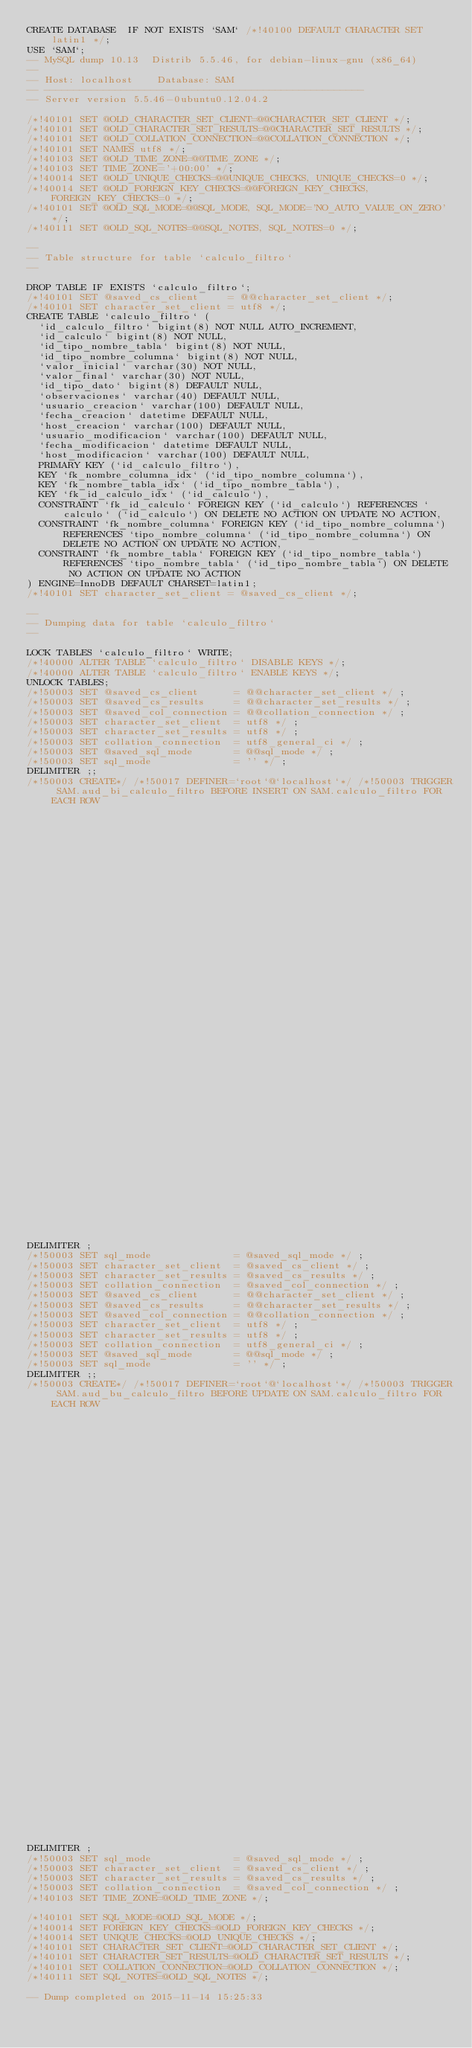<code> <loc_0><loc_0><loc_500><loc_500><_SQL_>CREATE DATABASE  IF NOT EXISTS `SAM` /*!40100 DEFAULT CHARACTER SET latin1 */;
USE `SAM`;
-- MySQL dump 10.13  Distrib 5.5.46, for debian-linux-gnu (x86_64)
--
-- Host: localhost    Database: SAM
-- ------------------------------------------------------
-- Server version	5.5.46-0ubuntu0.12.04.2

/*!40101 SET @OLD_CHARACTER_SET_CLIENT=@@CHARACTER_SET_CLIENT */;
/*!40101 SET @OLD_CHARACTER_SET_RESULTS=@@CHARACTER_SET_RESULTS */;
/*!40101 SET @OLD_COLLATION_CONNECTION=@@COLLATION_CONNECTION */;
/*!40101 SET NAMES utf8 */;
/*!40103 SET @OLD_TIME_ZONE=@@TIME_ZONE */;
/*!40103 SET TIME_ZONE='+00:00' */;
/*!40014 SET @OLD_UNIQUE_CHECKS=@@UNIQUE_CHECKS, UNIQUE_CHECKS=0 */;
/*!40014 SET @OLD_FOREIGN_KEY_CHECKS=@@FOREIGN_KEY_CHECKS, FOREIGN_KEY_CHECKS=0 */;
/*!40101 SET @OLD_SQL_MODE=@@SQL_MODE, SQL_MODE='NO_AUTO_VALUE_ON_ZERO' */;
/*!40111 SET @OLD_SQL_NOTES=@@SQL_NOTES, SQL_NOTES=0 */;

--
-- Table structure for table `calculo_filtro`
--

DROP TABLE IF EXISTS `calculo_filtro`;
/*!40101 SET @saved_cs_client     = @@character_set_client */;
/*!40101 SET character_set_client = utf8 */;
CREATE TABLE `calculo_filtro` (
  `id_calculo_filtro` bigint(8) NOT NULL AUTO_INCREMENT,
  `id_calculo` bigint(8) NOT NULL,
  `id_tipo_nombre_tabla` bigint(8) NOT NULL,
  `id_tipo_nombre_columna` bigint(8) NOT NULL,
  `valor_inicial` varchar(30) NOT NULL,
  `valor_final` varchar(30) NOT NULL,
  `id_tipo_dato` bigint(8) DEFAULT NULL,
  `observaciones` varchar(40) DEFAULT NULL,
  `usuario_creacion` varchar(100) DEFAULT NULL,
  `fecha_creacion` datetime DEFAULT NULL,
  `host_creacion` varchar(100) DEFAULT NULL,
  `usuario_modificacion` varchar(100) DEFAULT NULL,
  `fecha_modificacion` datetime DEFAULT NULL,
  `host_modificacion` varchar(100) DEFAULT NULL,
  PRIMARY KEY (`id_calculo_filtro`),
  KEY `fk_nombre_columna_idx` (`id_tipo_nombre_columna`),
  KEY `fk_nombre_tabla_idx` (`id_tipo_nombre_tabla`),
  KEY `fk_id_calculo_idx` (`id_calculo`),
  CONSTRAINT `fk_id_calculo` FOREIGN KEY (`id_calculo`) REFERENCES `calculo` (`id_calculo`) ON DELETE NO ACTION ON UPDATE NO ACTION,
  CONSTRAINT `fk_nombre_columna` FOREIGN KEY (`id_tipo_nombre_columna`) REFERENCES `tipo_nombre_columna` (`id_tipo_nombre_columna`) ON DELETE NO ACTION ON UPDATE NO ACTION,
  CONSTRAINT `fk_nombre_tabla` FOREIGN KEY (`id_tipo_nombre_tabla`) REFERENCES `tipo_nombre_tabla` (`id_tipo_nombre_tabla`) ON DELETE NO ACTION ON UPDATE NO ACTION
) ENGINE=InnoDB DEFAULT CHARSET=latin1;
/*!40101 SET character_set_client = @saved_cs_client */;

--
-- Dumping data for table `calculo_filtro`
--

LOCK TABLES `calculo_filtro` WRITE;
/*!40000 ALTER TABLE `calculo_filtro` DISABLE KEYS */;
/*!40000 ALTER TABLE `calculo_filtro` ENABLE KEYS */;
UNLOCK TABLES;
/*!50003 SET @saved_cs_client      = @@character_set_client */ ;
/*!50003 SET @saved_cs_results     = @@character_set_results */ ;
/*!50003 SET @saved_col_connection = @@collation_connection */ ;
/*!50003 SET character_set_client  = utf8 */ ;
/*!50003 SET character_set_results = utf8 */ ;
/*!50003 SET collation_connection  = utf8_general_ci */ ;
/*!50003 SET @saved_sql_mode       = @@sql_mode */ ;
/*!50003 SET sql_mode              = '' */ ;
DELIMITER ;;
/*!50003 CREATE*/ /*!50017 DEFINER=`root`@`localhost`*/ /*!50003 TRIGGER SAM.aud_bi_calculo_filtro BEFORE INSERT ON SAM.calculo_filtro FOR EACH ROW 
                                                                                BEGIN 
                                                                                	set new.fecha_creacion := NOW(); 
                                                                                	set new.usuario_creacion :=  user(); 
                                                                                	set new.host_creacion := user(); 
                                                                                END */;;
DELIMITER ;
/*!50003 SET sql_mode              = @saved_sql_mode */ ;
/*!50003 SET character_set_client  = @saved_cs_client */ ;
/*!50003 SET character_set_results = @saved_cs_results */ ;
/*!50003 SET collation_connection  = @saved_col_connection */ ;
/*!50003 SET @saved_cs_client      = @@character_set_client */ ;
/*!50003 SET @saved_cs_results     = @@character_set_results */ ;
/*!50003 SET @saved_col_connection = @@collation_connection */ ;
/*!50003 SET character_set_client  = utf8 */ ;
/*!50003 SET character_set_results = utf8 */ ;
/*!50003 SET collation_connection  = utf8_general_ci */ ;
/*!50003 SET @saved_sql_mode       = @@sql_mode */ ;
/*!50003 SET sql_mode              = '' */ ;
DELIMITER ;;
/*!50003 CREATE*/ /*!50017 DEFINER=`root`@`localhost`*/ /*!50003 TRIGGER SAM.aud_bu_calculo_filtro BEFORE UPDATE ON SAM.calculo_filtro FOR EACH ROW
                                                                                BEGIN
                                                                                	set new.fecha_modificacion := NOW();
                                                                                	set new.usuario_modificacion :=  user();
                                                                                	set new.host_modificacion := user();
                                                                                END */;;
DELIMITER ;
/*!50003 SET sql_mode              = @saved_sql_mode */ ;
/*!50003 SET character_set_client  = @saved_cs_client */ ;
/*!50003 SET character_set_results = @saved_cs_results */ ;
/*!50003 SET collation_connection  = @saved_col_connection */ ;
/*!40103 SET TIME_ZONE=@OLD_TIME_ZONE */;

/*!40101 SET SQL_MODE=@OLD_SQL_MODE */;
/*!40014 SET FOREIGN_KEY_CHECKS=@OLD_FOREIGN_KEY_CHECKS */;
/*!40014 SET UNIQUE_CHECKS=@OLD_UNIQUE_CHECKS */;
/*!40101 SET CHARACTER_SET_CLIENT=@OLD_CHARACTER_SET_CLIENT */;
/*!40101 SET CHARACTER_SET_RESULTS=@OLD_CHARACTER_SET_RESULTS */;
/*!40101 SET COLLATION_CONNECTION=@OLD_COLLATION_CONNECTION */;
/*!40111 SET SQL_NOTES=@OLD_SQL_NOTES */;

-- Dump completed on 2015-11-14 15:25:33
</code> 